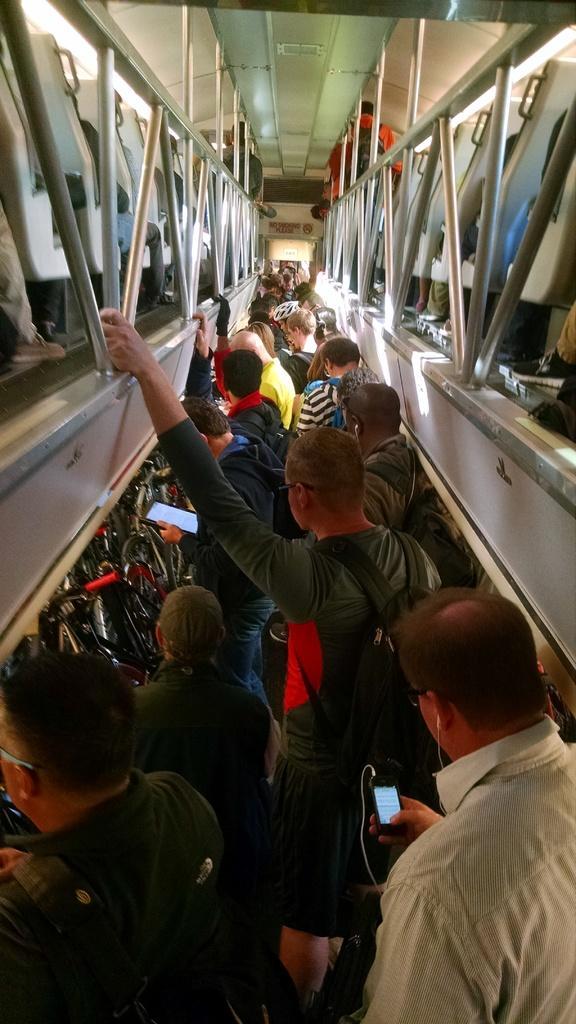In one or two sentences, can you explain what this image depicts? In this picture we can see inside of the vehicle, some people are walking in a path, above the people we can see some seats, grilles, we can see few people on the seats. 